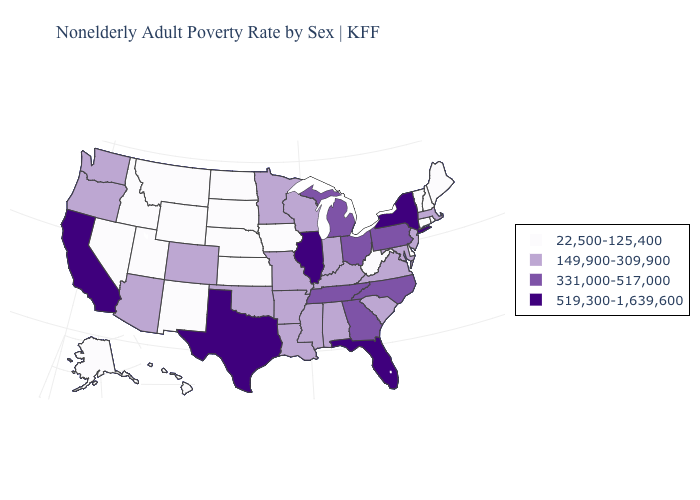What is the value of Oregon?
Be succinct. 149,900-309,900. What is the value of North Carolina?
Give a very brief answer. 331,000-517,000. Which states have the lowest value in the USA?
Concise answer only. Alaska, Connecticut, Delaware, Hawaii, Idaho, Iowa, Kansas, Maine, Montana, Nebraska, Nevada, New Hampshire, New Mexico, North Dakota, Rhode Island, South Dakota, Utah, Vermont, West Virginia, Wyoming. Among the states that border Minnesota , does Wisconsin have the lowest value?
Answer briefly. No. Among the states that border West Virginia , does Kentucky have the highest value?
Quick response, please. No. What is the value of Minnesota?
Be succinct. 149,900-309,900. What is the lowest value in the USA?
Quick response, please. 22,500-125,400. What is the highest value in the MidWest ?
Short answer required. 519,300-1,639,600. Does the map have missing data?
Keep it brief. No. Among the states that border Utah , does Idaho have the highest value?
Answer briefly. No. Does Texas have the lowest value in the USA?
Keep it brief. No. What is the value of Arkansas?
Quick response, please. 149,900-309,900. What is the lowest value in states that border Oregon?
Answer briefly. 22,500-125,400. What is the highest value in states that border South Dakota?
Give a very brief answer. 149,900-309,900. What is the value of Indiana?
Answer briefly. 149,900-309,900. 